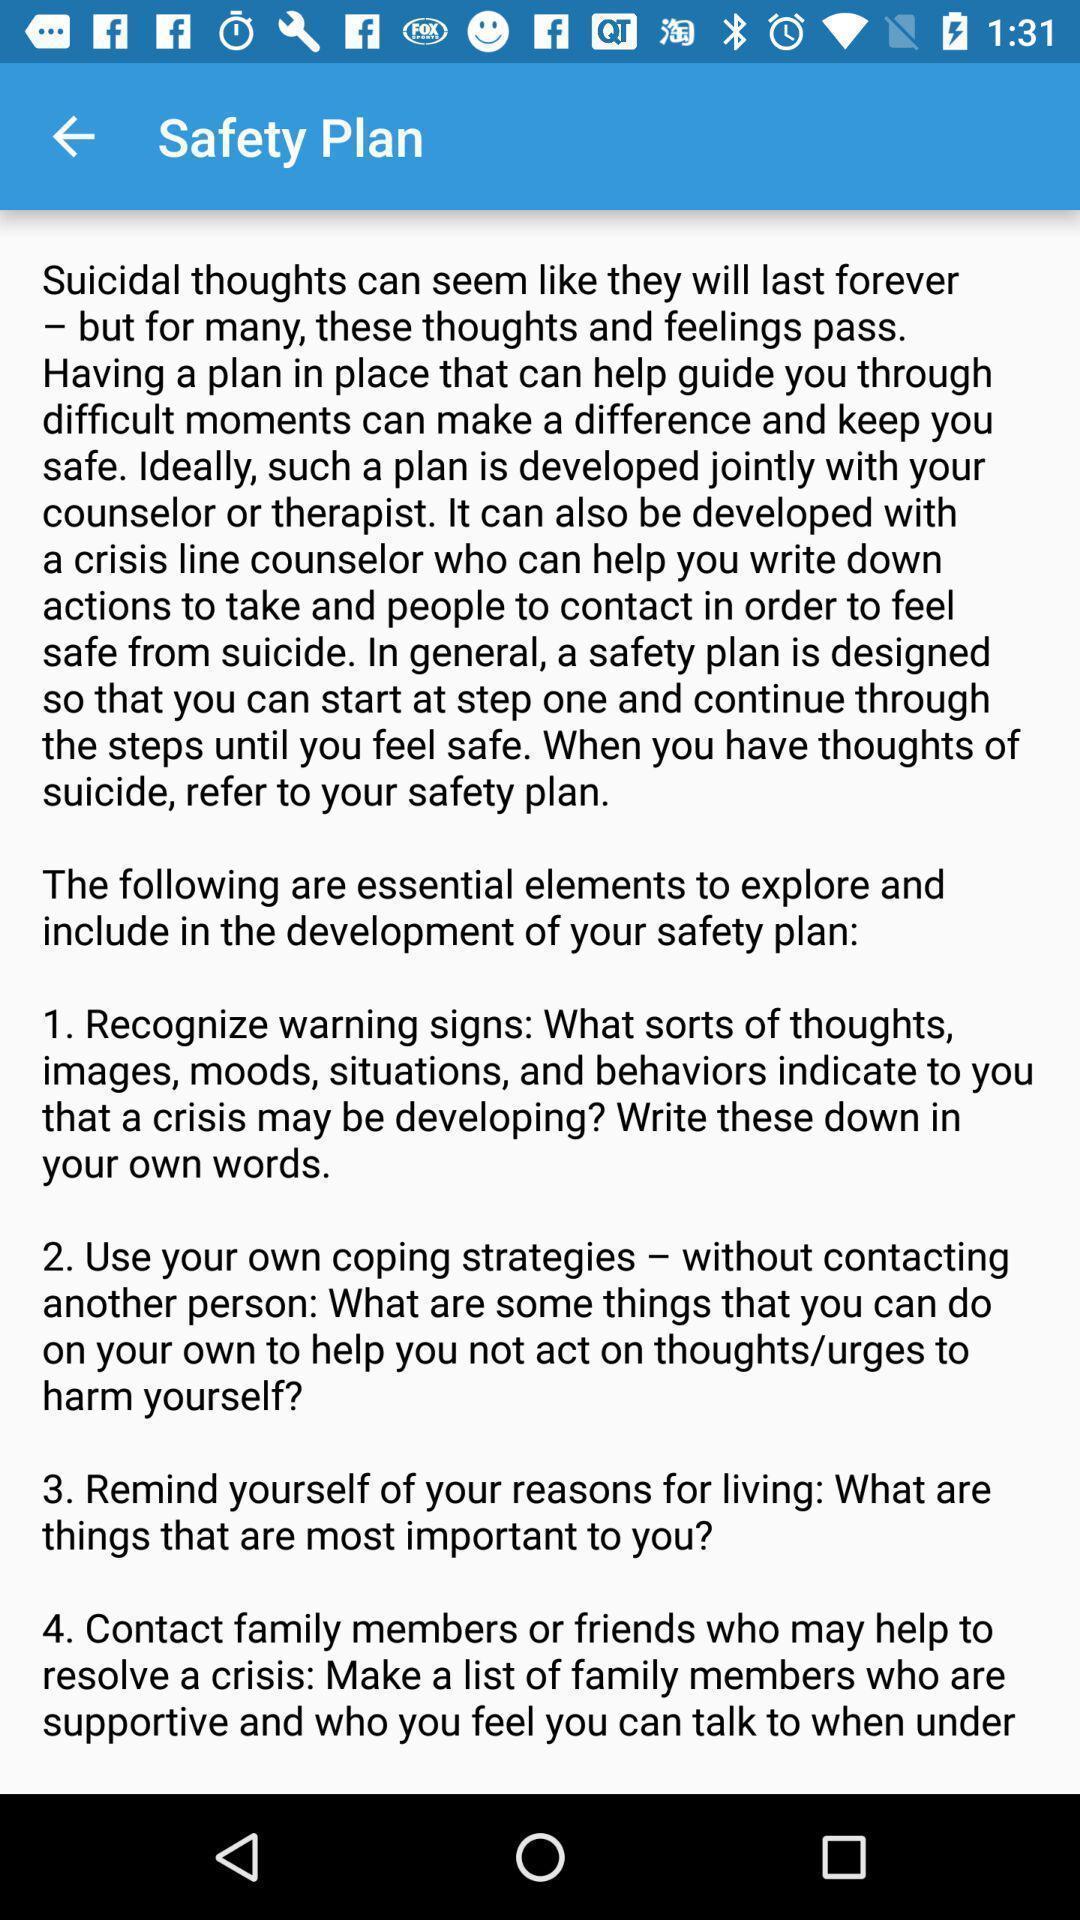Please provide a description for this image. Screen displaying the elements to explore safety. 